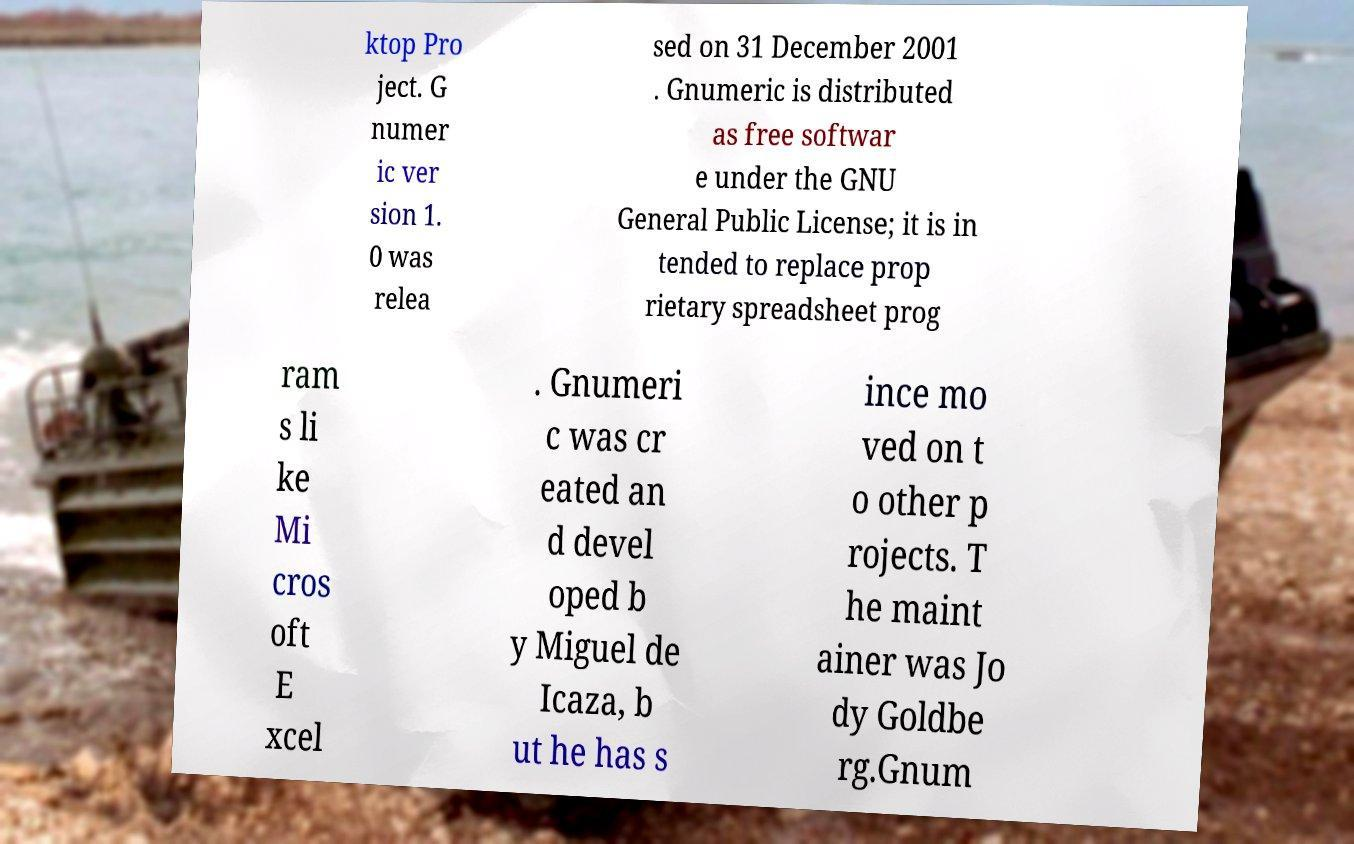What messages or text are displayed in this image? I need them in a readable, typed format. ktop Pro ject. G numer ic ver sion 1. 0 was relea sed on 31 December 2001 . Gnumeric is distributed as free softwar e under the GNU General Public License; it is in tended to replace prop rietary spreadsheet prog ram s li ke Mi cros oft E xcel . Gnumeri c was cr eated an d devel oped b y Miguel de Icaza, b ut he has s ince mo ved on t o other p rojects. T he maint ainer was Jo dy Goldbe rg.Gnum 